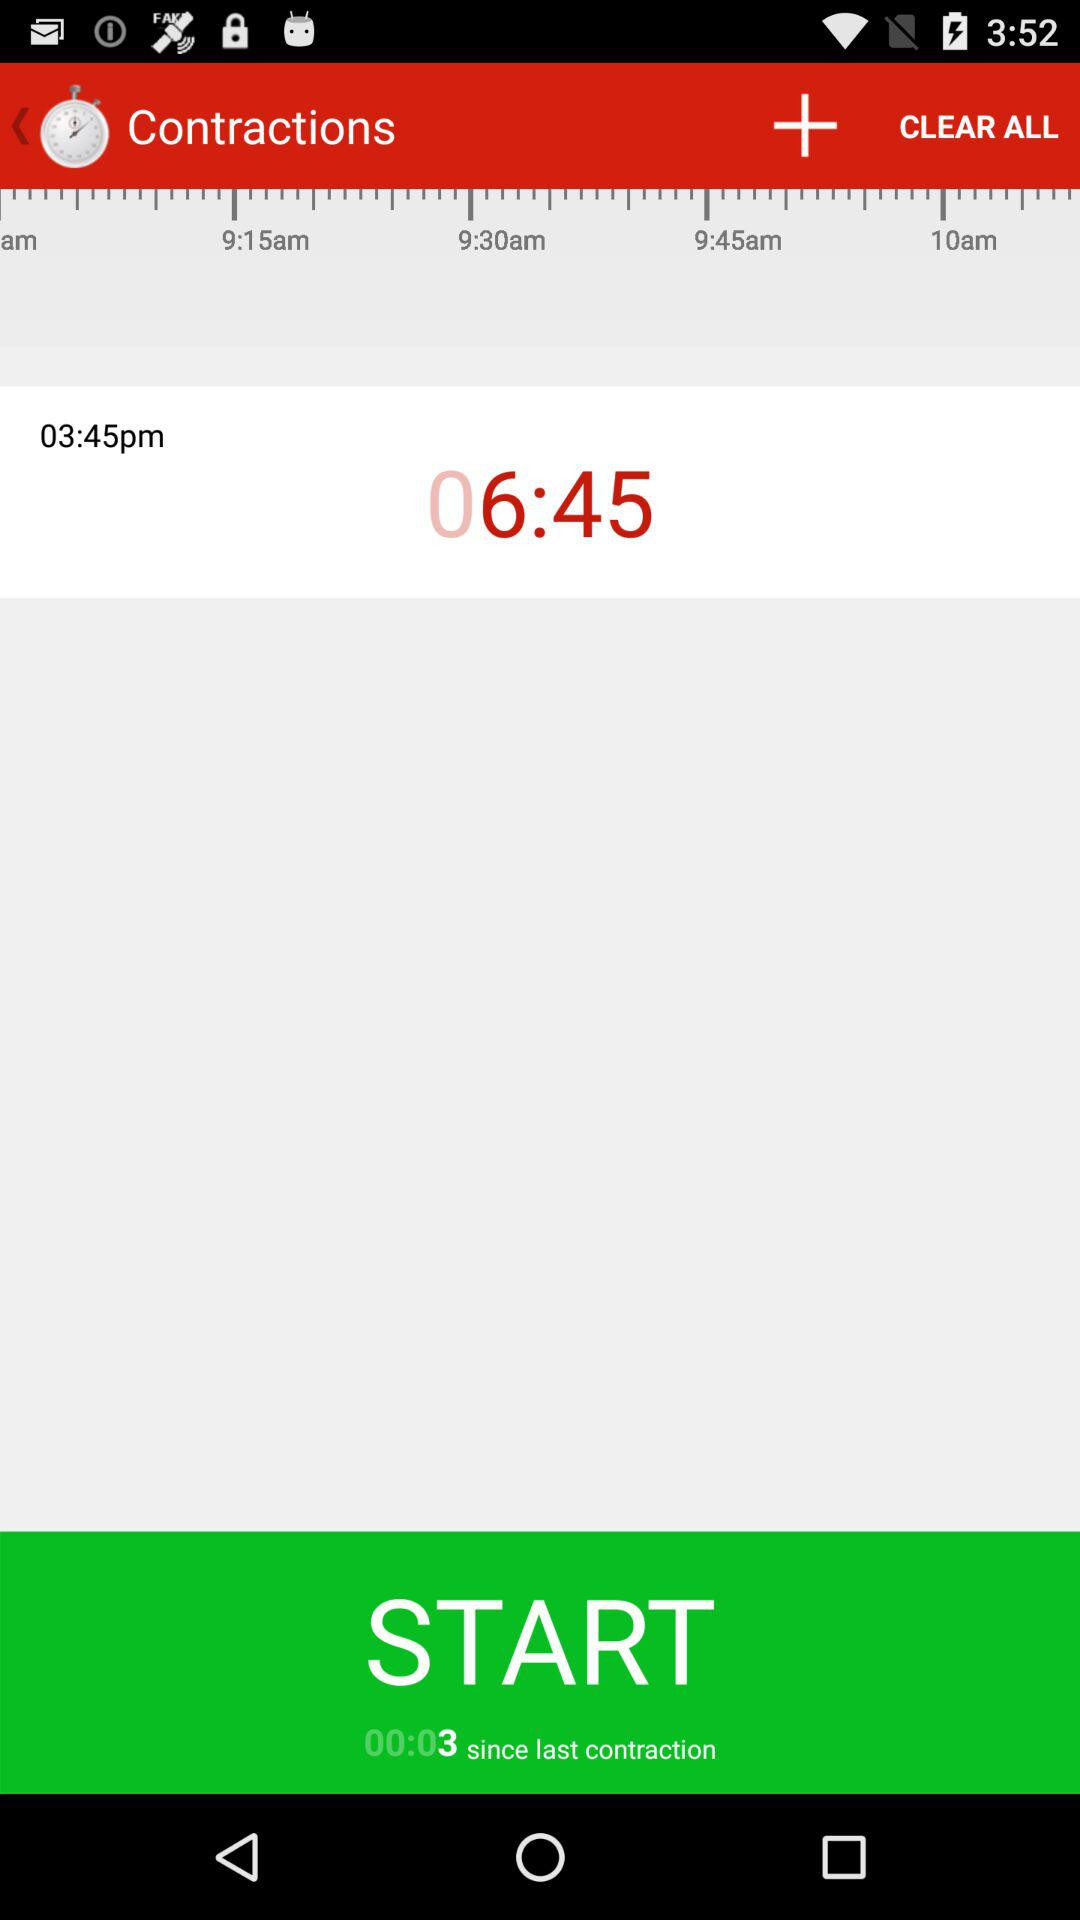What is the time displayed on the screen? The displayed time is 3:45 p.m. 